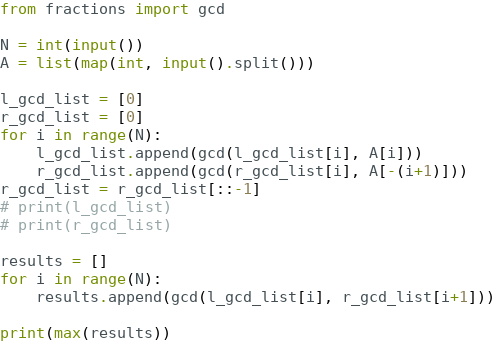Convert code to text. <code><loc_0><loc_0><loc_500><loc_500><_Python_>from fractions import gcd

N = int(input())
A = list(map(int, input().split()))

l_gcd_list = [0]
r_gcd_list = [0]
for i in range(N):
    l_gcd_list.append(gcd(l_gcd_list[i], A[i]))
    r_gcd_list.append(gcd(r_gcd_list[i], A[-(i+1)]))
r_gcd_list = r_gcd_list[::-1]
# print(l_gcd_list)
# print(r_gcd_list)

results = []
for i in range(N):
    results.append(gcd(l_gcd_list[i], r_gcd_list[i+1]))

print(max(results))
</code> 